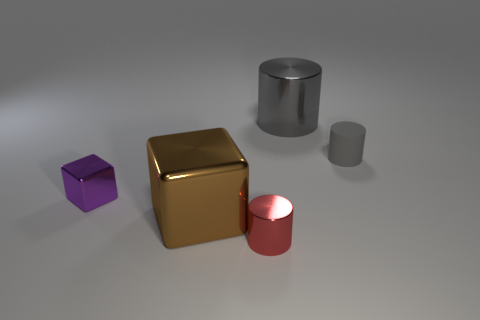What size is the thing that is to the left of the big thing that is in front of the small purple metal block?
Make the answer very short. Small. How many big metallic cylinders are the same color as the tiny metal cube?
Keep it short and to the point. 0. How many other objects are the same size as the purple thing?
Make the answer very short. 2. How big is the metallic object that is both on the right side of the big brown thing and on the left side of the large gray metallic object?
Your response must be concise. Small. How many other tiny matte objects are the same shape as the tiny red thing?
Offer a very short reply. 1. What material is the large cylinder?
Offer a terse response. Metal. Is the red thing the same shape as the small purple metallic object?
Your answer should be compact. No. Is there a big brown thing that has the same material as the big cylinder?
Offer a very short reply. Yes. What color is the object that is left of the small matte thing and behind the purple metallic cube?
Provide a succinct answer. Gray. There is a tiny cylinder on the right side of the big gray object; what material is it?
Offer a very short reply. Rubber. 